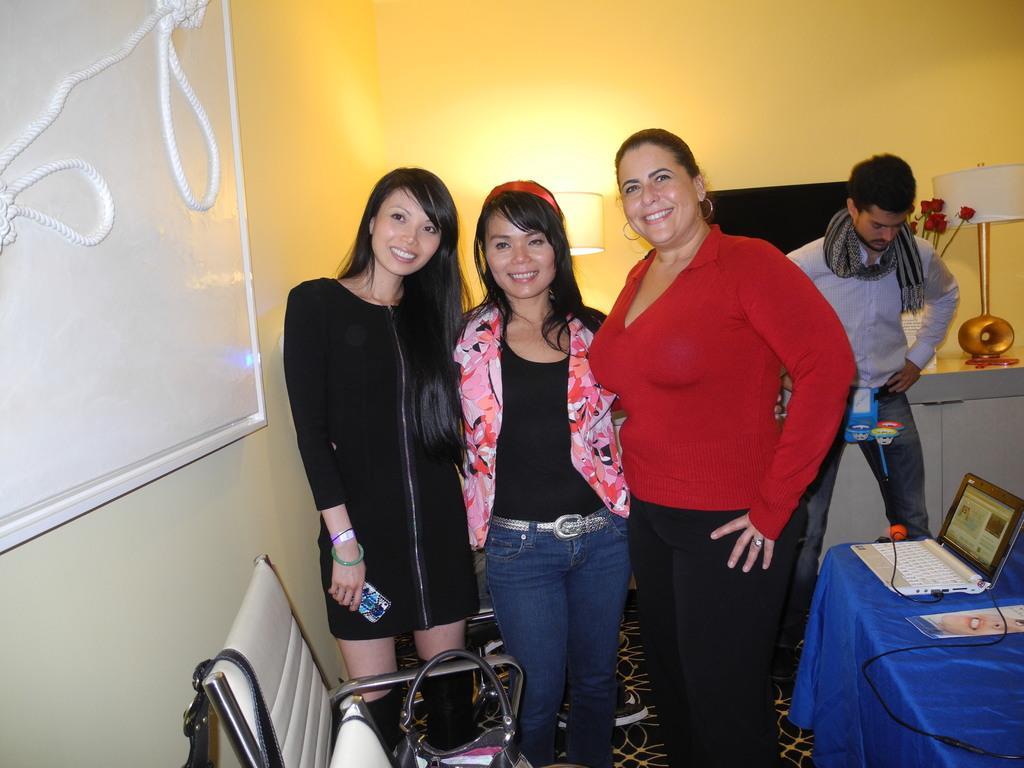Can you describe this image briefly? In the picture I can see three women standing on the floor and there is a smile on their faces. There is a woman on the left side is holding a mobile phone in her right hand. I can see a table on the floor on the bottom right side and there is a laptop on the table. I can see a man on the right side. In the background, I can see the television on the wall and table lamps on the wooden drawer. There is a white board on the wall on the left side and I can see the rope. I can see a chair on the floor at the bottom of the image and there is a bag on the chair. 